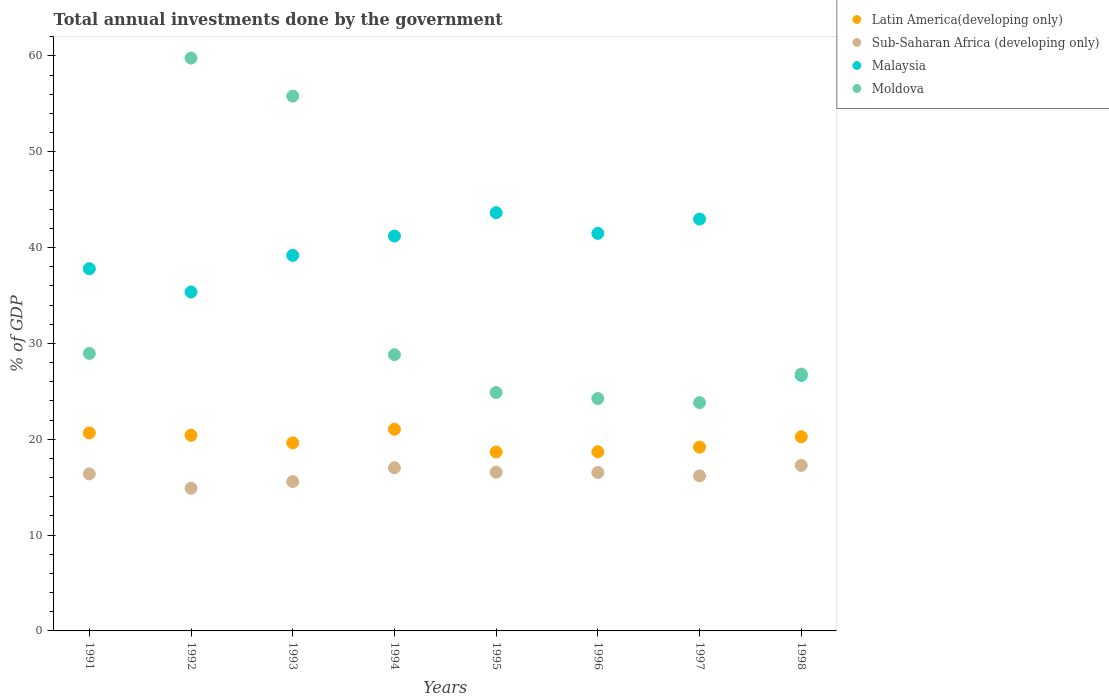How many different coloured dotlines are there?
Your response must be concise. 4. What is the total annual investments done by the government in Latin America(developing only) in 1991?
Your answer should be compact. 20.66. Across all years, what is the maximum total annual investments done by the government in Latin America(developing only)?
Offer a very short reply. 21.04. Across all years, what is the minimum total annual investments done by the government in Malaysia?
Your answer should be compact. 26.67. In which year was the total annual investments done by the government in Malaysia maximum?
Provide a short and direct response. 1995. In which year was the total annual investments done by the government in Moldova minimum?
Offer a very short reply. 1997. What is the total total annual investments done by the government in Sub-Saharan Africa (developing only) in the graph?
Offer a very short reply. 130.43. What is the difference between the total annual investments done by the government in Sub-Saharan Africa (developing only) in 1991 and that in 1995?
Provide a succinct answer. -0.18. What is the difference between the total annual investments done by the government in Latin America(developing only) in 1994 and the total annual investments done by the government in Sub-Saharan Africa (developing only) in 1997?
Your answer should be compact. 4.87. What is the average total annual investments done by the government in Sub-Saharan Africa (developing only) per year?
Provide a short and direct response. 16.3. In the year 1995, what is the difference between the total annual investments done by the government in Malaysia and total annual investments done by the government in Sub-Saharan Africa (developing only)?
Provide a succinct answer. 27.08. In how many years, is the total annual investments done by the government in Moldova greater than 16 %?
Ensure brevity in your answer.  8. What is the ratio of the total annual investments done by the government in Sub-Saharan Africa (developing only) in 1997 to that in 1998?
Offer a very short reply. 0.94. What is the difference between the highest and the second highest total annual investments done by the government in Sub-Saharan Africa (developing only)?
Make the answer very short. 0.25. What is the difference between the highest and the lowest total annual investments done by the government in Malaysia?
Offer a very short reply. 16.97. Is the sum of the total annual investments done by the government in Malaysia in 1995 and 1998 greater than the maximum total annual investments done by the government in Latin America(developing only) across all years?
Keep it short and to the point. Yes. Is it the case that in every year, the sum of the total annual investments done by the government in Malaysia and total annual investments done by the government in Latin America(developing only)  is greater than the total annual investments done by the government in Moldova?
Give a very brief answer. No. Is the total annual investments done by the government in Sub-Saharan Africa (developing only) strictly greater than the total annual investments done by the government in Malaysia over the years?
Your response must be concise. No. Is the total annual investments done by the government in Latin America(developing only) strictly less than the total annual investments done by the government in Malaysia over the years?
Offer a terse response. Yes. How many years are there in the graph?
Provide a short and direct response. 8. What is the difference between two consecutive major ticks on the Y-axis?
Make the answer very short. 10. Does the graph contain grids?
Offer a very short reply. No. Where does the legend appear in the graph?
Ensure brevity in your answer.  Top right. How many legend labels are there?
Make the answer very short. 4. How are the legend labels stacked?
Your response must be concise. Vertical. What is the title of the graph?
Your response must be concise. Total annual investments done by the government. Does "Iran" appear as one of the legend labels in the graph?
Make the answer very short. No. What is the label or title of the Y-axis?
Offer a terse response. % of GDP. What is the % of GDP in Latin America(developing only) in 1991?
Your answer should be compact. 20.66. What is the % of GDP of Sub-Saharan Africa (developing only) in 1991?
Ensure brevity in your answer.  16.38. What is the % of GDP of Malaysia in 1991?
Keep it short and to the point. 37.79. What is the % of GDP in Moldova in 1991?
Give a very brief answer. 28.96. What is the % of GDP of Latin America(developing only) in 1992?
Provide a short and direct response. 20.42. What is the % of GDP in Sub-Saharan Africa (developing only) in 1992?
Offer a very short reply. 14.89. What is the % of GDP in Malaysia in 1992?
Provide a short and direct response. 35.36. What is the % of GDP of Moldova in 1992?
Ensure brevity in your answer.  59.77. What is the % of GDP in Latin America(developing only) in 1993?
Your answer should be compact. 19.62. What is the % of GDP in Sub-Saharan Africa (developing only) in 1993?
Your answer should be very brief. 15.59. What is the % of GDP of Malaysia in 1993?
Ensure brevity in your answer.  39.18. What is the % of GDP of Moldova in 1993?
Your response must be concise. 55.8. What is the % of GDP in Latin America(developing only) in 1994?
Your answer should be very brief. 21.04. What is the % of GDP in Sub-Saharan Africa (developing only) in 1994?
Offer a very short reply. 17.03. What is the % of GDP of Malaysia in 1994?
Ensure brevity in your answer.  41.2. What is the % of GDP in Moldova in 1994?
Provide a short and direct response. 28.83. What is the % of GDP in Latin America(developing only) in 1995?
Provide a succinct answer. 18.67. What is the % of GDP in Sub-Saharan Africa (developing only) in 1995?
Your answer should be very brief. 16.56. What is the % of GDP in Malaysia in 1995?
Your response must be concise. 43.64. What is the % of GDP of Moldova in 1995?
Offer a terse response. 24.88. What is the % of GDP of Latin America(developing only) in 1996?
Make the answer very short. 18.69. What is the % of GDP of Sub-Saharan Africa (developing only) in 1996?
Offer a very short reply. 16.53. What is the % of GDP of Malaysia in 1996?
Offer a terse response. 41.48. What is the % of GDP of Moldova in 1996?
Make the answer very short. 24.25. What is the % of GDP in Latin America(developing only) in 1997?
Provide a short and direct response. 19.18. What is the % of GDP in Sub-Saharan Africa (developing only) in 1997?
Your answer should be very brief. 16.18. What is the % of GDP in Malaysia in 1997?
Provide a succinct answer. 42.97. What is the % of GDP of Moldova in 1997?
Give a very brief answer. 23.82. What is the % of GDP of Latin America(developing only) in 1998?
Keep it short and to the point. 20.26. What is the % of GDP in Sub-Saharan Africa (developing only) in 1998?
Keep it short and to the point. 17.28. What is the % of GDP in Malaysia in 1998?
Your answer should be very brief. 26.67. What is the % of GDP of Moldova in 1998?
Offer a very short reply. 26.8. Across all years, what is the maximum % of GDP in Latin America(developing only)?
Provide a succinct answer. 21.04. Across all years, what is the maximum % of GDP in Sub-Saharan Africa (developing only)?
Provide a short and direct response. 17.28. Across all years, what is the maximum % of GDP of Malaysia?
Ensure brevity in your answer.  43.64. Across all years, what is the maximum % of GDP of Moldova?
Make the answer very short. 59.77. Across all years, what is the minimum % of GDP in Latin America(developing only)?
Provide a short and direct response. 18.67. Across all years, what is the minimum % of GDP in Sub-Saharan Africa (developing only)?
Provide a succinct answer. 14.89. Across all years, what is the minimum % of GDP in Malaysia?
Your answer should be compact. 26.67. Across all years, what is the minimum % of GDP in Moldova?
Provide a short and direct response. 23.82. What is the total % of GDP of Latin America(developing only) in the graph?
Your response must be concise. 158.53. What is the total % of GDP in Sub-Saharan Africa (developing only) in the graph?
Make the answer very short. 130.43. What is the total % of GDP in Malaysia in the graph?
Your answer should be compact. 308.31. What is the total % of GDP of Moldova in the graph?
Offer a terse response. 273.1. What is the difference between the % of GDP of Latin America(developing only) in 1991 and that in 1992?
Ensure brevity in your answer.  0.24. What is the difference between the % of GDP in Sub-Saharan Africa (developing only) in 1991 and that in 1992?
Give a very brief answer. 1.5. What is the difference between the % of GDP in Malaysia in 1991 and that in 1992?
Your answer should be compact. 2.43. What is the difference between the % of GDP of Moldova in 1991 and that in 1992?
Provide a short and direct response. -30.81. What is the difference between the % of GDP of Latin America(developing only) in 1991 and that in 1993?
Offer a terse response. 1.04. What is the difference between the % of GDP in Sub-Saharan Africa (developing only) in 1991 and that in 1993?
Your response must be concise. 0.8. What is the difference between the % of GDP in Malaysia in 1991 and that in 1993?
Provide a succinct answer. -1.39. What is the difference between the % of GDP of Moldova in 1991 and that in 1993?
Provide a succinct answer. -26.84. What is the difference between the % of GDP of Latin America(developing only) in 1991 and that in 1994?
Offer a terse response. -0.39. What is the difference between the % of GDP of Sub-Saharan Africa (developing only) in 1991 and that in 1994?
Your response must be concise. -0.64. What is the difference between the % of GDP in Malaysia in 1991 and that in 1994?
Offer a very short reply. -3.41. What is the difference between the % of GDP in Moldova in 1991 and that in 1994?
Your answer should be compact. 0.13. What is the difference between the % of GDP in Latin America(developing only) in 1991 and that in 1995?
Provide a short and direct response. 1.99. What is the difference between the % of GDP in Sub-Saharan Africa (developing only) in 1991 and that in 1995?
Your answer should be compact. -0.18. What is the difference between the % of GDP of Malaysia in 1991 and that in 1995?
Ensure brevity in your answer.  -5.85. What is the difference between the % of GDP in Moldova in 1991 and that in 1995?
Your answer should be very brief. 4.08. What is the difference between the % of GDP of Latin America(developing only) in 1991 and that in 1996?
Provide a short and direct response. 1.97. What is the difference between the % of GDP of Sub-Saharan Africa (developing only) in 1991 and that in 1996?
Your answer should be compact. -0.14. What is the difference between the % of GDP of Malaysia in 1991 and that in 1996?
Keep it short and to the point. -3.69. What is the difference between the % of GDP in Moldova in 1991 and that in 1996?
Provide a short and direct response. 4.71. What is the difference between the % of GDP of Latin America(developing only) in 1991 and that in 1997?
Provide a succinct answer. 1.48. What is the difference between the % of GDP in Sub-Saharan Africa (developing only) in 1991 and that in 1997?
Provide a short and direct response. 0.21. What is the difference between the % of GDP of Malaysia in 1991 and that in 1997?
Your response must be concise. -5.18. What is the difference between the % of GDP of Moldova in 1991 and that in 1997?
Provide a succinct answer. 5.14. What is the difference between the % of GDP in Latin America(developing only) in 1991 and that in 1998?
Provide a short and direct response. 0.4. What is the difference between the % of GDP of Sub-Saharan Africa (developing only) in 1991 and that in 1998?
Ensure brevity in your answer.  -0.89. What is the difference between the % of GDP in Malaysia in 1991 and that in 1998?
Your answer should be very brief. 11.12. What is the difference between the % of GDP in Moldova in 1991 and that in 1998?
Make the answer very short. 2.16. What is the difference between the % of GDP of Latin America(developing only) in 1992 and that in 1993?
Provide a succinct answer. 0.8. What is the difference between the % of GDP in Sub-Saharan Africa (developing only) in 1992 and that in 1993?
Offer a terse response. -0.7. What is the difference between the % of GDP in Malaysia in 1992 and that in 1993?
Keep it short and to the point. -3.82. What is the difference between the % of GDP in Moldova in 1992 and that in 1993?
Your response must be concise. 3.97. What is the difference between the % of GDP of Latin America(developing only) in 1992 and that in 1994?
Provide a short and direct response. -0.63. What is the difference between the % of GDP of Sub-Saharan Africa (developing only) in 1992 and that in 1994?
Keep it short and to the point. -2.14. What is the difference between the % of GDP of Malaysia in 1992 and that in 1994?
Provide a short and direct response. -5.84. What is the difference between the % of GDP of Moldova in 1992 and that in 1994?
Your answer should be compact. 30.95. What is the difference between the % of GDP in Latin America(developing only) in 1992 and that in 1995?
Ensure brevity in your answer.  1.75. What is the difference between the % of GDP in Sub-Saharan Africa (developing only) in 1992 and that in 1995?
Offer a very short reply. -1.68. What is the difference between the % of GDP of Malaysia in 1992 and that in 1995?
Your answer should be very brief. -8.28. What is the difference between the % of GDP in Moldova in 1992 and that in 1995?
Provide a succinct answer. 34.89. What is the difference between the % of GDP in Latin America(developing only) in 1992 and that in 1996?
Provide a succinct answer. 1.72. What is the difference between the % of GDP of Sub-Saharan Africa (developing only) in 1992 and that in 1996?
Your response must be concise. -1.64. What is the difference between the % of GDP of Malaysia in 1992 and that in 1996?
Your answer should be very brief. -6.12. What is the difference between the % of GDP of Moldova in 1992 and that in 1996?
Make the answer very short. 35.52. What is the difference between the % of GDP of Latin America(developing only) in 1992 and that in 1997?
Offer a very short reply. 1.24. What is the difference between the % of GDP of Sub-Saharan Africa (developing only) in 1992 and that in 1997?
Your response must be concise. -1.29. What is the difference between the % of GDP of Malaysia in 1992 and that in 1997?
Offer a very short reply. -7.61. What is the difference between the % of GDP of Moldova in 1992 and that in 1997?
Your answer should be compact. 35.95. What is the difference between the % of GDP of Latin America(developing only) in 1992 and that in 1998?
Your response must be concise. 0.16. What is the difference between the % of GDP of Sub-Saharan Africa (developing only) in 1992 and that in 1998?
Offer a terse response. -2.39. What is the difference between the % of GDP of Malaysia in 1992 and that in 1998?
Your answer should be compact. 8.69. What is the difference between the % of GDP in Moldova in 1992 and that in 1998?
Provide a succinct answer. 32.97. What is the difference between the % of GDP in Latin America(developing only) in 1993 and that in 1994?
Provide a succinct answer. -1.43. What is the difference between the % of GDP in Sub-Saharan Africa (developing only) in 1993 and that in 1994?
Make the answer very short. -1.44. What is the difference between the % of GDP in Malaysia in 1993 and that in 1994?
Offer a very short reply. -2.02. What is the difference between the % of GDP of Moldova in 1993 and that in 1994?
Make the answer very short. 26.97. What is the difference between the % of GDP of Latin America(developing only) in 1993 and that in 1995?
Provide a short and direct response. 0.95. What is the difference between the % of GDP of Sub-Saharan Africa (developing only) in 1993 and that in 1995?
Give a very brief answer. -0.98. What is the difference between the % of GDP in Malaysia in 1993 and that in 1995?
Ensure brevity in your answer.  -4.46. What is the difference between the % of GDP in Moldova in 1993 and that in 1995?
Give a very brief answer. 30.92. What is the difference between the % of GDP of Latin America(developing only) in 1993 and that in 1996?
Provide a succinct answer. 0.93. What is the difference between the % of GDP of Sub-Saharan Africa (developing only) in 1993 and that in 1996?
Offer a terse response. -0.94. What is the difference between the % of GDP of Malaysia in 1993 and that in 1996?
Provide a short and direct response. -2.3. What is the difference between the % of GDP of Moldova in 1993 and that in 1996?
Your response must be concise. 31.55. What is the difference between the % of GDP in Latin America(developing only) in 1993 and that in 1997?
Your response must be concise. 0.44. What is the difference between the % of GDP in Sub-Saharan Africa (developing only) in 1993 and that in 1997?
Offer a terse response. -0.59. What is the difference between the % of GDP of Malaysia in 1993 and that in 1997?
Offer a very short reply. -3.79. What is the difference between the % of GDP in Moldova in 1993 and that in 1997?
Ensure brevity in your answer.  31.98. What is the difference between the % of GDP in Latin America(developing only) in 1993 and that in 1998?
Keep it short and to the point. -0.64. What is the difference between the % of GDP of Sub-Saharan Africa (developing only) in 1993 and that in 1998?
Ensure brevity in your answer.  -1.69. What is the difference between the % of GDP of Malaysia in 1993 and that in 1998?
Your answer should be very brief. 12.51. What is the difference between the % of GDP in Moldova in 1993 and that in 1998?
Keep it short and to the point. 29. What is the difference between the % of GDP in Latin America(developing only) in 1994 and that in 1995?
Provide a short and direct response. 2.37. What is the difference between the % of GDP of Sub-Saharan Africa (developing only) in 1994 and that in 1995?
Offer a very short reply. 0.46. What is the difference between the % of GDP of Malaysia in 1994 and that in 1995?
Make the answer very short. -2.44. What is the difference between the % of GDP in Moldova in 1994 and that in 1995?
Provide a short and direct response. 3.95. What is the difference between the % of GDP in Latin America(developing only) in 1994 and that in 1996?
Provide a short and direct response. 2.35. What is the difference between the % of GDP in Sub-Saharan Africa (developing only) in 1994 and that in 1996?
Keep it short and to the point. 0.5. What is the difference between the % of GDP in Malaysia in 1994 and that in 1996?
Make the answer very short. -0.28. What is the difference between the % of GDP of Moldova in 1994 and that in 1996?
Keep it short and to the point. 4.58. What is the difference between the % of GDP of Latin America(developing only) in 1994 and that in 1997?
Offer a terse response. 1.87. What is the difference between the % of GDP in Sub-Saharan Africa (developing only) in 1994 and that in 1997?
Ensure brevity in your answer.  0.85. What is the difference between the % of GDP in Malaysia in 1994 and that in 1997?
Make the answer very short. -1.77. What is the difference between the % of GDP of Moldova in 1994 and that in 1997?
Offer a very short reply. 5. What is the difference between the % of GDP in Latin America(developing only) in 1994 and that in 1998?
Give a very brief answer. 0.79. What is the difference between the % of GDP of Sub-Saharan Africa (developing only) in 1994 and that in 1998?
Give a very brief answer. -0.25. What is the difference between the % of GDP of Malaysia in 1994 and that in 1998?
Ensure brevity in your answer.  14.53. What is the difference between the % of GDP of Moldova in 1994 and that in 1998?
Provide a succinct answer. 2.02. What is the difference between the % of GDP in Latin America(developing only) in 1995 and that in 1996?
Give a very brief answer. -0.02. What is the difference between the % of GDP of Sub-Saharan Africa (developing only) in 1995 and that in 1996?
Provide a short and direct response. 0.04. What is the difference between the % of GDP in Malaysia in 1995 and that in 1996?
Your answer should be very brief. 2.16. What is the difference between the % of GDP of Moldova in 1995 and that in 1996?
Provide a short and direct response. 0.63. What is the difference between the % of GDP in Latin America(developing only) in 1995 and that in 1997?
Make the answer very short. -0.51. What is the difference between the % of GDP in Sub-Saharan Africa (developing only) in 1995 and that in 1997?
Provide a succinct answer. 0.39. What is the difference between the % of GDP in Malaysia in 1995 and that in 1997?
Offer a terse response. 0.67. What is the difference between the % of GDP of Moldova in 1995 and that in 1997?
Make the answer very short. 1.05. What is the difference between the % of GDP in Latin America(developing only) in 1995 and that in 1998?
Your response must be concise. -1.59. What is the difference between the % of GDP of Sub-Saharan Africa (developing only) in 1995 and that in 1998?
Your response must be concise. -0.71. What is the difference between the % of GDP of Malaysia in 1995 and that in 1998?
Provide a succinct answer. 16.97. What is the difference between the % of GDP in Moldova in 1995 and that in 1998?
Provide a short and direct response. -1.93. What is the difference between the % of GDP of Latin America(developing only) in 1996 and that in 1997?
Make the answer very short. -0.49. What is the difference between the % of GDP of Sub-Saharan Africa (developing only) in 1996 and that in 1997?
Your response must be concise. 0.35. What is the difference between the % of GDP in Malaysia in 1996 and that in 1997?
Offer a very short reply. -1.49. What is the difference between the % of GDP in Moldova in 1996 and that in 1997?
Your answer should be compact. 0.43. What is the difference between the % of GDP of Latin America(developing only) in 1996 and that in 1998?
Offer a terse response. -1.57. What is the difference between the % of GDP of Sub-Saharan Africa (developing only) in 1996 and that in 1998?
Your answer should be very brief. -0.75. What is the difference between the % of GDP of Malaysia in 1996 and that in 1998?
Ensure brevity in your answer.  14.8. What is the difference between the % of GDP in Moldova in 1996 and that in 1998?
Keep it short and to the point. -2.55. What is the difference between the % of GDP of Latin America(developing only) in 1997 and that in 1998?
Your answer should be very brief. -1.08. What is the difference between the % of GDP of Sub-Saharan Africa (developing only) in 1997 and that in 1998?
Offer a very short reply. -1.1. What is the difference between the % of GDP in Malaysia in 1997 and that in 1998?
Give a very brief answer. 16.3. What is the difference between the % of GDP of Moldova in 1997 and that in 1998?
Your answer should be very brief. -2.98. What is the difference between the % of GDP of Latin America(developing only) in 1991 and the % of GDP of Sub-Saharan Africa (developing only) in 1992?
Your answer should be very brief. 5.77. What is the difference between the % of GDP of Latin America(developing only) in 1991 and the % of GDP of Malaysia in 1992?
Provide a succinct answer. -14.71. What is the difference between the % of GDP in Latin America(developing only) in 1991 and the % of GDP in Moldova in 1992?
Offer a very short reply. -39.11. What is the difference between the % of GDP in Sub-Saharan Africa (developing only) in 1991 and the % of GDP in Malaysia in 1992?
Give a very brief answer. -18.98. What is the difference between the % of GDP of Sub-Saharan Africa (developing only) in 1991 and the % of GDP of Moldova in 1992?
Offer a terse response. -43.39. What is the difference between the % of GDP in Malaysia in 1991 and the % of GDP in Moldova in 1992?
Your response must be concise. -21.98. What is the difference between the % of GDP of Latin America(developing only) in 1991 and the % of GDP of Sub-Saharan Africa (developing only) in 1993?
Ensure brevity in your answer.  5.07. What is the difference between the % of GDP in Latin America(developing only) in 1991 and the % of GDP in Malaysia in 1993?
Make the answer very short. -18.53. What is the difference between the % of GDP of Latin America(developing only) in 1991 and the % of GDP of Moldova in 1993?
Your answer should be compact. -35.14. What is the difference between the % of GDP of Sub-Saharan Africa (developing only) in 1991 and the % of GDP of Malaysia in 1993?
Your answer should be compact. -22.8. What is the difference between the % of GDP of Sub-Saharan Africa (developing only) in 1991 and the % of GDP of Moldova in 1993?
Offer a terse response. -39.42. What is the difference between the % of GDP of Malaysia in 1991 and the % of GDP of Moldova in 1993?
Offer a very short reply. -18.01. What is the difference between the % of GDP in Latin America(developing only) in 1991 and the % of GDP in Sub-Saharan Africa (developing only) in 1994?
Your response must be concise. 3.63. What is the difference between the % of GDP of Latin America(developing only) in 1991 and the % of GDP of Malaysia in 1994?
Make the answer very short. -20.54. What is the difference between the % of GDP in Latin America(developing only) in 1991 and the % of GDP in Moldova in 1994?
Your answer should be very brief. -8.17. What is the difference between the % of GDP of Sub-Saharan Africa (developing only) in 1991 and the % of GDP of Malaysia in 1994?
Give a very brief answer. -24.82. What is the difference between the % of GDP in Sub-Saharan Africa (developing only) in 1991 and the % of GDP in Moldova in 1994?
Give a very brief answer. -12.44. What is the difference between the % of GDP of Malaysia in 1991 and the % of GDP of Moldova in 1994?
Your answer should be compact. 8.97. What is the difference between the % of GDP in Latin America(developing only) in 1991 and the % of GDP in Sub-Saharan Africa (developing only) in 1995?
Ensure brevity in your answer.  4.09. What is the difference between the % of GDP in Latin America(developing only) in 1991 and the % of GDP in Malaysia in 1995?
Ensure brevity in your answer.  -22.98. What is the difference between the % of GDP of Latin America(developing only) in 1991 and the % of GDP of Moldova in 1995?
Make the answer very short. -4.22. What is the difference between the % of GDP of Sub-Saharan Africa (developing only) in 1991 and the % of GDP of Malaysia in 1995?
Provide a succinct answer. -27.26. What is the difference between the % of GDP in Sub-Saharan Africa (developing only) in 1991 and the % of GDP in Moldova in 1995?
Keep it short and to the point. -8.49. What is the difference between the % of GDP of Malaysia in 1991 and the % of GDP of Moldova in 1995?
Your response must be concise. 12.91. What is the difference between the % of GDP of Latin America(developing only) in 1991 and the % of GDP of Sub-Saharan Africa (developing only) in 1996?
Ensure brevity in your answer.  4.13. What is the difference between the % of GDP in Latin America(developing only) in 1991 and the % of GDP in Malaysia in 1996?
Provide a short and direct response. -20.82. What is the difference between the % of GDP of Latin America(developing only) in 1991 and the % of GDP of Moldova in 1996?
Offer a very short reply. -3.59. What is the difference between the % of GDP in Sub-Saharan Africa (developing only) in 1991 and the % of GDP in Malaysia in 1996?
Offer a terse response. -25.1. What is the difference between the % of GDP of Sub-Saharan Africa (developing only) in 1991 and the % of GDP of Moldova in 1996?
Make the answer very short. -7.86. What is the difference between the % of GDP in Malaysia in 1991 and the % of GDP in Moldova in 1996?
Ensure brevity in your answer.  13.54. What is the difference between the % of GDP of Latin America(developing only) in 1991 and the % of GDP of Sub-Saharan Africa (developing only) in 1997?
Your answer should be compact. 4.48. What is the difference between the % of GDP in Latin America(developing only) in 1991 and the % of GDP in Malaysia in 1997?
Provide a succinct answer. -22.32. What is the difference between the % of GDP of Latin America(developing only) in 1991 and the % of GDP of Moldova in 1997?
Ensure brevity in your answer.  -3.16. What is the difference between the % of GDP in Sub-Saharan Africa (developing only) in 1991 and the % of GDP in Malaysia in 1997?
Provide a short and direct response. -26.59. What is the difference between the % of GDP in Sub-Saharan Africa (developing only) in 1991 and the % of GDP in Moldova in 1997?
Your answer should be compact. -7.44. What is the difference between the % of GDP of Malaysia in 1991 and the % of GDP of Moldova in 1997?
Provide a short and direct response. 13.97. What is the difference between the % of GDP in Latin America(developing only) in 1991 and the % of GDP in Sub-Saharan Africa (developing only) in 1998?
Ensure brevity in your answer.  3.38. What is the difference between the % of GDP of Latin America(developing only) in 1991 and the % of GDP of Malaysia in 1998?
Your answer should be compact. -6.02. What is the difference between the % of GDP in Latin America(developing only) in 1991 and the % of GDP in Moldova in 1998?
Make the answer very short. -6.14. What is the difference between the % of GDP of Sub-Saharan Africa (developing only) in 1991 and the % of GDP of Malaysia in 1998?
Ensure brevity in your answer.  -10.29. What is the difference between the % of GDP in Sub-Saharan Africa (developing only) in 1991 and the % of GDP in Moldova in 1998?
Provide a succinct answer. -10.42. What is the difference between the % of GDP of Malaysia in 1991 and the % of GDP of Moldova in 1998?
Your answer should be very brief. 10.99. What is the difference between the % of GDP in Latin America(developing only) in 1992 and the % of GDP in Sub-Saharan Africa (developing only) in 1993?
Offer a terse response. 4.83. What is the difference between the % of GDP in Latin America(developing only) in 1992 and the % of GDP in Malaysia in 1993?
Your answer should be very brief. -18.77. What is the difference between the % of GDP in Latin America(developing only) in 1992 and the % of GDP in Moldova in 1993?
Your answer should be very brief. -35.38. What is the difference between the % of GDP in Sub-Saharan Africa (developing only) in 1992 and the % of GDP in Malaysia in 1993?
Give a very brief answer. -24.3. What is the difference between the % of GDP in Sub-Saharan Africa (developing only) in 1992 and the % of GDP in Moldova in 1993?
Provide a short and direct response. -40.91. What is the difference between the % of GDP of Malaysia in 1992 and the % of GDP of Moldova in 1993?
Provide a short and direct response. -20.44. What is the difference between the % of GDP in Latin America(developing only) in 1992 and the % of GDP in Sub-Saharan Africa (developing only) in 1994?
Your answer should be compact. 3.39. What is the difference between the % of GDP of Latin America(developing only) in 1992 and the % of GDP of Malaysia in 1994?
Offer a terse response. -20.79. What is the difference between the % of GDP of Latin America(developing only) in 1992 and the % of GDP of Moldova in 1994?
Your response must be concise. -8.41. What is the difference between the % of GDP of Sub-Saharan Africa (developing only) in 1992 and the % of GDP of Malaysia in 1994?
Your answer should be very brief. -26.32. What is the difference between the % of GDP of Sub-Saharan Africa (developing only) in 1992 and the % of GDP of Moldova in 1994?
Give a very brief answer. -13.94. What is the difference between the % of GDP in Malaysia in 1992 and the % of GDP in Moldova in 1994?
Offer a very short reply. 6.54. What is the difference between the % of GDP of Latin America(developing only) in 1992 and the % of GDP of Sub-Saharan Africa (developing only) in 1995?
Provide a short and direct response. 3.85. What is the difference between the % of GDP in Latin America(developing only) in 1992 and the % of GDP in Malaysia in 1995?
Offer a very short reply. -23.22. What is the difference between the % of GDP in Latin America(developing only) in 1992 and the % of GDP in Moldova in 1995?
Ensure brevity in your answer.  -4.46. What is the difference between the % of GDP in Sub-Saharan Africa (developing only) in 1992 and the % of GDP in Malaysia in 1995?
Give a very brief answer. -28.75. What is the difference between the % of GDP of Sub-Saharan Africa (developing only) in 1992 and the % of GDP of Moldova in 1995?
Your answer should be compact. -9.99. What is the difference between the % of GDP in Malaysia in 1992 and the % of GDP in Moldova in 1995?
Your answer should be very brief. 10.49. What is the difference between the % of GDP of Latin America(developing only) in 1992 and the % of GDP of Sub-Saharan Africa (developing only) in 1996?
Give a very brief answer. 3.89. What is the difference between the % of GDP in Latin America(developing only) in 1992 and the % of GDP in Malaysia in 1996?
Keep it short and to the point. -21.06. What is the difference between the % of GDP in Latin America(developing only) in 1992 and the % of GDP in Moldova in 1996?
Keep it short and to the point. -3.83. What is the difference between the % of GDP in Sub-Saharan Africa (developing only) in 1992 and the % of GDP in Malaysia in 1996?
Offer a terse response. -26.59. What is the difference between the % of GDP in Sub-Saharan Africa (developing only) in 1992 and the % of GDP in Moldova in 1996?
Keep it short and to the point. -9.36. What is the difference between the % of GDP in Malaysia in 1992 and the % of GDP in Moldova in 1996?
Provide a succinct answer. 11.12. What is the difference between the % of GDP of Latin America(developing only) in 1992 and the % of GDP of Sub-Saharan Africa (developing only) in 1997?
Provide a short and direct response. 4.24. What is the difference between the % of GDP in Latin America(developing only) in 1992 and the % of GDP in Malaysia in 1997?
Your answer should be compact. -22.56. What is the difference between the % of GDP of Latin America(developing only) in 1992 and the % of GDP of Moldova in 1997?
Make the answer very short. -3.41. What is the difference between the % of GDP in Sub-Saharan Africa (developing only) in 1992 and the % of GDP in Malaysia in 1997?
Ensure brevity in your answer.  -28.09. What is the difference between the % of GDP in Sub-Saharan Africa (developing only) in 1992 and the % of GDP in Moldova in 1997?
Your answer should be compact. -8.94. What is the difference between the % of GDP in Malaysia in 1992 and the % of GDP in Moldova in 1997?
Your answer should be very brief. 11.54. What is the difference between the % of GDP of Latin America(developing only) in 1992 and the % of GDP of Sub-Saharan Africa (developing only) in 1998?
Make the answer very short. 3.14. What is the difference between the % of GDP in Latin America(developing only) in 1992 and the % of GDP in Malaysia in 1998?
Give a very brief answer. -6.26. What is the difference between the % of GDP of Latin America(developing only) in 1992 and the % of GDP of Moldova in 1998?
Provide a succinct answer. -6.39. What is the difference between the % of GDP of Sub-Saharan Africa (developing only) in 1992 and the % of GDP of Malaysia in 1998?
Your answer should be very brief. -11.79. What is the difference between the % of GDP in Sub-Saharan Africa (developing only) in 1992 and the % of GDP in Moldova in 1998?
Ensure brevity in your answer.  -11.92. What is the difference between the % of GDP in Malaysia in 1992 and the % of GDP in Moldova in 1998?
Give a very brief answer. 8.56. What is the difference between the % of GDP in Latin America(developing only) in 1993 and the % of GDP in Sub-Saharan Africa (developing only) in 1994?
Keep it short and to the point. 2.59. What is the difference between the % of GDP in Latin America(developing only) in 1993 and the % of GDP in Malaysia in 1994?
Offer a very short reply. -21.59. What is the difference between the % of GDP of Latin America(developing only) in 1993 and the % of GDP of Moldova in 1994?
Offer a very short reply. -9.21. What is the difference between the % of GDP of Sub-Saharan Africa (developing only) in 1993 and the % of GDP of Malaysia in 1994?
Your answer should be very brief. -25.62. What is the difference between the % of GDP of Sub-Saharan Africa (developing only) in 1993 and the % of GDP of Moldova in 1994?
Keep it short and to the point. -13.24. What is the difference between the % of GDP in Malaysia in 1993 and the % of GDP in Moldova in 1994?
Your response must be concise. 10.36. What is the difference between the % of GDP in Latin America(developing only) in 1993 and the % of GDP in Sub-Saharan Africa (developing only) in 1995?
Ensure brevity in your answer.  3.05. What is the difference between the % of GDP in Latin America(developing only) in 1993 and the % of GDP in Malaysia in 1995?
Provide a succinct answer. -24.02. What is the difference between the % of GDP in Latin America(developing only) in 1993 and the % of GDP in Moldova in 1995?
Your answer should be very brief. -5.26. What is the difference between the % of GDP in Sub-Saharan Africa (developing only) in 1993 and the % of GDP in Malaysia in 1995?
Provide a succinct answer. -28.05. What is the difference between the % of GDP of Sub-Saharan Africa (developing only) in 1993 and the % of GDP of Moldova in 1995?
Provide a short and direct response. -9.29. What is the difference between the % of GDP of Malaysia in 1993 and the % of GDP of Moldova in 1995?
Your answer should be very brief. 14.31. What is the difference between the % of GDP of Latin America(developing only) in 1993 and the % of GDP of Sub-Saharan Africa (developing only) in 1996?
Offer a very short reply. 3.09. What is the difference between the % of GDP of Latin America(developing only) in 1993 and the % of GDP of Malaysia in 1996?
Give a very brief answer. -21.86. What is the difference between the % of GDP in Latin America(developing only) in 1993 and the % of GDP in Moldova in 1996?
Provide a succinct answer. -4.63. What is the difference between the % of GDP of Sub-Saharan Africa (developing only) in 1993 and the % of GDP of Malaysia in 1996?
Offer a very short reply. -25.89. What is the difference between the % of GDP in Sub-Saharan Africa (developing only) in 1993 and the % of GDP in Moldova in 1996?
Offer a terse response. -8.66. What is the difference between the % of GDP in Malaysia in 1993 and the % of GDP in Moldova in 1996?
Your response must be concise. 14.94. What is the difference between the % of GDP in Latin America(developing only) in 1993 and the % of GDP in Sub-Saharan Africa (developing only) in 1997?
Provide a short and direct response. 3.44. What is the difference between the % of GDP of Latin America(developing only) in 1993 and the % of GDP of Malaysia in 1997?
Ensure brevity in your answer.  -23.36. What is the difference between the % of GDP in Latin America(developing only) in 1993 and the % of GDP in Moldova in 1997?
Provide a succinct answer. -4.2. What is the difference between the % of GDP in Sub-Saharan Africa (developing only) in 1993 and the % of GDP in Malaysia in 1997?
Provide a succinct answer. -27.39. What is the difference between the % of GDP in Sub-Saharan Africa (developing only) in 1993 and the % of GDP in Moldova in 1997?
Make the answer very short. -8.24. What is the difference between the % of GDP in Malaysia in 1993 and the % of GDP in Moldova in 1997?
Your answer should be compact. 15.36. What is the difference between the % of GDP of Latin America(developing only) in 1993 and the % of GDP of Sub-Saharan Africa (developing only) in 1998?
Provide a short and direct response. 2.34. What is the difference between the % of GDP in Latin America(developing only) in 1993 and the % of GDP in Malaysia in 1998?
Offer a very short reply. -7.06. What is the difference between the % of GDP of Latin America(developing only) in 1993 and the % of GDP of Moldova in 1998?
Provide a short and direct response. -7.18. What is the difference between the % of GDP of Sub-Saharan Africa (developing only) in 1993 and the % of GDP of Malaysia in 1998?
Keep it short and to the point. -11.09. What is the difference between the % of GDP of Sub-Saharan Africa (developing only) in 1993 and the % of GDP of Moldova in 1998?
Your response must be concise. -11.21. What is the difference between the % of GDP of Malaysia in 1993 and the % of GDP of Moldova in 1998?
Your answer should be very brief. 12.38. What is the difference between the % of GDP of Latin America(developing only) in 1994 and the % of GDP of Sub-Saharan Africa (developing only) in 1995?
Offer a very short reply. 4.48. What is the difference between the % of GDP in Latin America(developing only) in 1994 and the % of GDP in Malaysia in 1995?
Ensure brevity in your answer.  -22.6. What is the difference between the % of GDP in Latin America(developing only) in 1994 and the % of GDP in Moldova in 1995?
Keep it short and to the point. -3.83. What is the difference between the % of GDP of Sub-Saharan Africa (developing only) in 1994 and the % of GDP of Malaysia in 1995?
Give a very brief answer. -26.61. What is the difference between the % of GDP of Sub-Saharan Africa (developing only) in 1994 and the % of GDP of Moldova in 1995?
Your response must be concise. -7.85. What is the difference between the % of GDP of Malaysia in 1994 and the % of GDP of Moldova in 1995?
Make the answer very short. 16.33. What is the difference between the % of GDP in Latin America(developing only) in 1994 and the % of GDP in Sub-Saharan Africa (developing only) in 1996?
Provide a short and direct response. 4.52. What is the difference between the % of GDP of Latin America(developing only) in 1994 and the % of GDP of Malaysia in 1996?
Your answer should be very brief. -20.44. What is the difference between the % of GDP of Latin America(developing only) in 1994 and the % of GDP of Moldova in 1996?
Keep it short and to the point. -3.2. What is the difference between the % of GDP of Sub-Saharan Africa (developing only) in 1994 and the % of GDP of Malaysia in 1996?
Keep it short and to the point. -24.45. What is the difference between the % of GDP of Sub-Saharan Africa (developing only) in 1994 and the % of GDP of Moldova in 1996?
Give a very brief answer. -7.22. What is the difference between the % of GDP in Malaysia in 1994 and the % of GDP in Moldova in 1996?
Give a very brief answer. 16.96. What is the difference between the % of GDP of Latin America(developing only) in 1994 and the % of GDP of Sub-Saharan Africa (developing only) in 1997?
Provide a short and direct response. 4.87. What is the difference between the % of GDP in Latin America(developing only) in 1994 and the % of GDP in Malaysia in 1997?
Provide a succinct answer. -21.93. What is the difference between the % of GDP of Latin America(developing only) in 1994 and the % of GDP of Moldova in 1997?
Provide a succinct answer. -2.78. What is the difference between the % of GDP in Sub-Saharan Africa (developing only) in 1994 and the % of GDP in Malaysia in 1997?
Ensure brevity in your answer.  -25.95. What is the difference between the % of GDP in Sub-Saharan Africa (developing only) in 1994 and the % of GDP in Moldova in 1997?
Offer a terse response. -6.8. What is the difference between the % of GDP of Malaysia in 1994 and the % of GDP of Moldova in 1997?
Provide a succinct answer. 17.38. What is the difference between the % of GDP in Latin America(developing only) in 1994 and the % of GDP in Sub-Saharan Africa (developing only) in 1998?
Provide a succinct answer. 3.77. What is the difference between the % of GDP in Latin America(developing only) in 1994 and the % of GDP in Malaysia in 1998?
Your answer should be very brief. -5.63. What is the difference between the % of GDP of Latin America(developing only) in 1994 and the % of GDP of Moldova in 1998?
Offer a very short reply. -5.76. What is the difference between the % of GDP in Sub-Saharan Africa (developing only) in 1994 and the % of GDP in Malaysia in 1998?
Your answer should be very brief. -9.65. What is the difference between the % of GDP of Sub-Saharan Africa (developing only) in 1994 and the % of GDP of Moldova in 1998?
Your response must be concise. -9.77. What is the difference between the % of GDP in Malaysia in 1994 and the % of GDP in Moldova in 1998?
Your answer should be compact. 14.4. What is the difference between the % of GDP of Latin America(developing only) in 1995 and the % of GDP of Sub-Saharan Africa (developing only) in 1996?
Make the answer very short. 2.14. What is the difference between the % of GDP of Latin America(developing only) in 1995 and the % of GDP of Malaysia in 1996?
Your answer should be compact. -22.81. What is the difference between the % of GDP of Latin America(developing only) in 1995 and the % of GDP of Moldova in 1996?
Provide a short and direct response. -5.58. What is the difference between the % of GDP in Sub-Saharan Africa (developing only) in 1995 and the % of GDP in Malaysia in 1996?
Give a very brief answer. -24.91. What is the difference between the % of GDP of Sub-Saharan Africa (developing only) in 1995 and the % of GDP of Moldova in 1996?
Keep it short and to the point. -7.68. What is the difference between the % of GDP in Malaysia in 1995 and the % of GDP in Moldova in 1996?
Your answer should be very brief. 19.39. What is the difference between the % of GDP in Latin America(developing only) in 1995 and the % of GDP in Sub-Saharan Africa (developing only) in 1997?
Provide a short and direct response. 2.49. What is the difference between the % of GDP of Latin America(developing only) in 1995 and the % of GDP of Malaysia in 1997?
Your answer should be very brief. -24.3. What is the difference between the % of GDP of Latin America(developing only) in 1995 and the % of GDP of Moldova in 1997?
Give a very brief answer. -5.15. What is the difference between the % of GDP in Sub-Saharan Africa (developing only) in 1995 and the % of GDP in Malaysia in 1997?
Keep it short and to the point. -26.41. What is the difference between the % of GDP of Sub-Saharan Africa (developing only) in 1995 and the % of GDP of Moldova in 1997?
Make the answer very short. -7.26. What is the difference between the % of GDP in Malaysia in 1995 and the % of GDP in Moldova in 1997?
Keep it short and to the point. 19.82. What is the difference between the % of GDP of Latin America(developing only) in 1995 and the % of GDP of Sub-Saharan Africa (developing only) in 1998?
Your response must be concise. 1.39. What is the difference between the % of GDP of Latin America(developing only) in 1995 and the % of GDP of Malaysia in 1998?
Your answer should be very brief. -8. What is the difference between the % of GDP in Latin America(developing only) in 1995 and the % of GDP in Moldova in 1998?
Make the answer very short. -8.13. What is the difference between the % of GDP of Sub-Saharan Africa (developing only) in 1995 and the % of GDP of Malaysia in 1998?
Your answer should be very brief. -10.11. What is the difference between the % of GDP of Sub-Saharan Africa (developing only) in 1995 and the % of GDP of Moldova in 1998?
Ensure brevity in your answer.  -10.24. What is the difference between the % of GDP in Malaysia in 1995 and the % of GDP in Moldova in 1998?
Offer a very short reply. 16.84. What is the difference between the % of GDP in Latin America(developing only) in 1996 and the % of GDP in Sub-Saharan Africa (developing only) in 1997?
Make the answer very short. 2.51. What is the difference between the % of GDP in Latin America(developing only) in 1996 and the % of GDP in Malaysia in 1997?
Your answer should be compact. -24.28. What is the difference between the % of GDP of Latin America(developing only) in 1996 and the % of GDP of Moldova in 1997?
Your response must be concise. -5.13. What is the difference between the % of GDP of Sub-Saharan Africa (developing only) in 1996 and the % of GDP of Malaysia in 1997?
Your response must be concise. -26.45. What is the difference between the % of GDP of Sub-Saharan Africa (developing only) in 1996 and the % of GDP of Moldova in 1997?
Your response must be concise. -7.29. What is the difference between the % of GDP of Malaysia in 1996 and the % of GDP of Moldova in 1997?
Your response must be concise. 17.66. What is the difference between the % of GDP in Latin America(developing only) in 1996 and the % of GDP in Sub-Saharan Africa (developing only) in 1998?
Keep it short and to the point. 1.41. What is the difference between the % of GDP of Latin America(developing only) in 1996 and the % of GDP of Malaysia in 1998?
Make the answer very short. -7.98. What is the difference between the % of GDP in Latin America(developing only) in 1996 and the % of GDP in Moldova in 1998?
Provide a succinct answer. -8.11. What is the difference between the % of GDP in Sub-Saharan Africa (developing only) in 1996 and the % of GDP in Malaysia in 1998?
Your answer should be compact. -10.15. What is the difference between the % of GDP of Sub-Saharan Africa (developing only) in 1996 and the % of GDP of Moldova in 1998?
Offer a very short reply. -10.27. What is the difference between the % of GDP of Malaysia in 1996 and the % of GDP of Moldova in 1998?
Your answer should be very brief. 14.68. What is the difference between the % of GDP in Latin America(developing only) in 1997 and the % of GDP in Sub-Saharan Africa (developing only) in 1998?
Provide a short and direct response. 1.9. What is the difference between the % of GDP of Latin America(developing only) in 1997 and the % of GDP of Malaysia in 1998?
Make the answer very short. -7.5. What is the difference between the % of GDP in Latin America(developing only) in 1997 and the % of GDP in Moldova in 1998?
Offer a terse response. -7.62. What is the difference between the % of GDP in Sub-Saharan Africa (developing only) in 1997 and the % of GDP in Malaysia in 1998?
Your response must be concise. -10.5. What is the difference between the % of GDP of Sub-Saharan Africa (developing only) in 1997 and the % of GDP of Moldova in 1998?
Ensure brevity in your answer.  -10.62. What is the difference between the % of GDP in Malaysia in 1997 and the % of GDP in Moldova in 1998?
Offer a terse response. 16.17. What is the average % of GDP of Latin America(developing only) per year?
Give a very brief answer. 19.82. What is the average % of GDP of Sub-Saharan Africa (developing only) per year?
Keep it short and to the point. 16.3. What is the average % of GDP of Malaysia per year?
Offer a terse response. 38.54. What is the average % of GDP of Moldova per year?
Your answer should be very brief. 34.14. In the year 1991, what is the difference between the % of GDP in Latin America(developing only) and % of GDP in Sub-Saharan Africa (developing only)?
Your answer should be compact. 4.27. In the year 1991, what is the difference between the % of GDP in Latin America(developing only) and % of GDP in Malaysia?
Keep it short and to the point. -17.13. In the year 1991, what is the difference between the % of GDP in Latin America(developing only) and % of GDP in Moldova?
Your answer should be compact. -8.3. In the year 1991, what is the difference between the % of GDP in Sub-Saharan Africa (developing only) and % of GDP in Malaysia?
Provide a short and direct response. -21.41. In the year 1991, what is the difference between the % of GDP of Sub-Saharan Africa (developing only) and % of GDP of Moldova?
Your answer should be very brief. -12.57. In the year 1991, what is the difference between the % of GDP in Malaysia and % of GDP in Moldova?
Provide a short and direct response. 8.83. In the year 1992, what is the difference between the % of GDP of Latin America(developing only) and % of GDP of Sub-Saharan Africa (developing only)?
Your answer should be very brief. 5.53. In the year 1992, what is the difference between the % of GDP of Latin America(developing only) and % of GDP of Malaysia?
Give a very brief answer. -14.95. In the year 1992, what is the difference between the % of GDP in Latin America(developing only) and % of GDP in Moldova?
Provide a short and direct response. -39.36. In the year 1992, what is the difference between the % of GDP of Sub-Saharan Africa (developing only) and % of GDP of Malaysia?
Your response must be concise. -20.48. In the year 1992, what is the difference between the % of GDP of Sub-Saharan Africa (developing only) and % of GDP of Moldova?
Give a very brief answer. -44.88. In the year 1992, what is the difference between the % of GDP of Malaysia and % of GDP of Moldova?
Provide a short and direct response. -24.41. In the year 1993, what is the difference between the % of GDP in Latin America(developing only) and % of GDP in Sub-Saharan Africa (developing only)?
Keep it short and to the point. 4.03. In the year 1993, what is the difference between the % of GDP of Latin America(developing only) and % of GDP of Malaysia?
Give a very brief answer. -19.57. In the year 1993, what is the difference between the % of GDP of Latin America(developing only) and % of GDP of Moldova?
Provide a short and direct response. -36.18. In the year 1993, what is the difference between the % of GDP of Sub-Saharan Africa (developing only) and % of GDP of Malaysia?
Keep it short and to the point. -23.6. In the year 1993, what is the difference between the % of GDP in Sub-Saharan Africa (developing only) and % of GDP in Moldova?
Ensure brevity in your answer.  -40.21. In the year 1993, what is the difference between the % of GDP of Malaysia and % of GDP of Moldova?
Make the answer very short. -16.62. In the year 1994, what is the difference between the % of GDP in Latin America(developing only) and % of GDP in Sub-Saharan Africa (developing only)?
Offer a terse response. 4.02. In the year 1994, what is the difference between the % of GDP in Latin America(developing only) and % of GDP in Malaysia?
Your answer should be very brief. -20.16. In the year 1994, what is the difference between the % of GDP in Latin America(developing only) and % of GDP in Moldova?
Keep it short and to the point. -7.78. In the year 1994, what is the difference between the % of GDP of Sub-Saharan Africa (developing only) and % of GDP of Malaysia?
Your response must be concise. -24.18. In the year 1994, what is the difference between the % of GDP of Sub-Saharan Africa (developing only) and % of GDP of Moldova?
Your answer should be compact. -11.8. In the year 1994, what is the difference between the % of GDP in Malaysia and % of GDP in Moldova?
Keep it short and to the point. 12.38. In the year 1995, what is the difference between the % of GDP of Latin America(developing only) and % of GDP of Sub-Saharan Africa (developing only)?
Your response must be concise. 2.11. In the year 1995, what is the difference between the % of GDP of Latin America(developing only) and % of GDP of Malaysia?
Make the answer very short. -24.97. In the year 1995, what is the difference between the % of GDP in Latin America(developing only) and % of GDP in Moldova?
Provide a short and direct response. -6.21. In the year 1995, what is the difference between the % of GDP of Sub-Saharan Africa (developing only) and % of GDP of Malaysia?
Offer a terse response. -27.08. In the year 1995, what is the difference between the % of GDP in Sub-Saharan Africa (developing only) and % of GDP in Moldova?
Make the answer very short. -8.31. In the year 1995, what is the difference between the % of GDP in Malaysia and % of GDP in Moldova?
Your response must be concise. 18.76. In the year 1996, what is the difference between the % of GDP in Latin America(developing only) and % of GDP in Sub-Saharan Africa (developing only)?
Keep it short and to the point. 2.16. In the year 1996, what is the difference between the % of GDP of Latin America(developing only) and % of GDP of Malaysia?
Your answer should be compact. -22.79. In the year 1996, what is the difference between the % of GDP of Latin America(developing only) and % of GDP of Moldova?
Ensure brevity in your answer.  -5.56. In the year 1996, what is the difference between the % of GDP in Sub-Saharan Africa (developing only) and % of GDP in Malaysia?
Ensure brevity in your answer.  -24.95. In the year 1996, what is the difference between the % of GDP in Sub-Saharan Africa (developing only) and % of GDP in Moldova?
Give a very brief answer. -7.72. In the year 1996, what is the difference between the % of GDP of Malaysia and % of GDP of Moldova?
Provide a short and direct response. 17.23. In the year 1997, what is the difference between the % of GDP in Latin America(developing only) and % of GDP in Sub-Saharan Africa (developing only)?
Provide a short and direct response. 3. In the year 1997, what is the difference between the % of GDP in Latin America(developing only) and % of GDP in Malaysia?
Provide a short and direct response. -23.8. In the year 1997, what is the difference between the % of GDP in Latin America(developing only) and % of GDP in Moldova?
Your answer should be very brief. -4.65. In the year 1997, what is the difference between the % of GDP of Sub-Saharan Africa (developing only) and % of GDP of Malaysia?
Provide a short and direct response. -26.8. In the year 1997, what is the difference between the % of GDP in Sub-Saharan Africa (developing only) and % of GDP in Moldova?
Your response must be concise. -7.64. In the year 1997, what is the difference between the % of GDP in Malaysia and % of GDP in Moldova?
Your answer should be very brief. 19.15. In the year 1998, what is the difference between the % of GDP of Latin America(developing only) and % of GDP of Sub-Saharan Africa (developing only)?
Provide a short and direct response. 2.98. In the year 1998, what is the difference between the % of GDP in Latin America(developing only) and % of GDP in Malaysia?
Keep it short and to the point. -6.42. In the year 1998, what is the difference between the % of GDP of Latin America(developing only) and % of GDP of Moldova?
Make the answer very short. -6.54. In the year 1998, what is the difference between the % of GDP of Sub-Saharan Africa (developing only) and % of GDP of Malaysia?
Your answer should be compact. -9.4. In the year 1998, what is the difference between the % of GDP of Sub-Saharan Africa (developing only) and % of GDP of Moldova?
Make the answer very short. -9.53. In the year 1998, what is the difference between the % of GDP in Malaysia and % of GDP in Moldova?
Your answer should be compact. -0.13. What is the ratio of the % of GDP in Latin America(developing only) in 1991 to that in 1992?
Your answer should be compact. 1.01. What is the ratio of the % of GDP of Sub-Saharan Africa (developing only) in 1991 to that in 1992?
Your response must be concise. 1.1. What is the ratio of the % of GDP in Malaysia in 1991 to that in 1992?
Your response must be concise. 1.07. What is the ratio of the % of GDP of Moldova in 1991 to that in 1992?
Keep it short and to the point. 0.48. What is the ratio of the % of GDP in Latin America(developing only) in 1991 to that in 1993?
Your answer should be very brief. 1.05. What is the ratio of the % of GDP of Sub-Saharan Africa (developing only) in 1991 to that in 1993?
Offer a very short reply. 1.05. What is the ratio of the % of GDP of Malaysia in 1991 to that in 1993?
Your response must be concise. 0.96. What is the ratio of the % of GDP in Moldova in 1991 to that in 1993?
Offer a very short reply. 0.52. What is the ratio of the % of GDP in Latin America(developing only) in 1991 to that in 1994?
Your answer should be very brief. 0.98. What is the ratio of the % of GDP of Sub-Saharan Africa (developing only) in 1991 to that in 1994?
Your answer should be very brief. 0.96. What is the ratio of the % of GDP in Malaysia in 1991 to that in 1994?
Provide a short and direct response. 0.92. What is the ratio of the % of GDP in Moldova in 1991 to that in 1994?
Offer a very short reply. 1. What is the ratio of the % of GDP in Latin America(developing only) in 1991 to that in 1995?
Give a very brief answer. 1.11. What is the ratio of the % of GDP in Malaysia in 1991 to that in 1995?
Provide a succinct answer. 0.87. What is the ratio of the % of GDP of Moldova in 1991 to that in 1995?
Offer a very short reply. 1.16. What is the ratio of the % of GDP in Latin America(developing only) in 1991 to that in 1996?
Your response must be concise. 1.11. What is the ratio of the % of GDP in Malaysia in 1991 to that in 1996?
Offer a terse response. 0.91. What is the ratio of the % of GDP in Moldova in 1991 to that in 1996?
Your answer should be very brief. 1.19. What is the ratio of the % of GDP in Latin America(developing only) in 1991 to that in 1997?
Provide a succinct answer. 1.08. What is the ratio of the % of GDP of Sub-Saharan Africa (developing only) in 1991 to that in 1997?
Offer a terse response. 1.01. What is the ratio of the % of GDP in Malaysia in 1991 to that in 1997?
Make the answer very short. 0.88. What is the ratio of the % of GDP of Moldova in 1991 to that in 1997?
Ensure brevity in your answer.  1.22. What is the ratio of the % of GDP in Latin America(developing only) in 1991 to that in 1998?
Make the answer very short. 1.02. What is the ratio of the % of GDP of Sub-Saharan Africa (developing only) in 1991 to that in 1998?
Keep it short and to the point. 0.95. What is the ratio of the % of GDP in Malaysia in 1991 to that in 1998?
Ensure brevity in your answer.  1.42. What is the ratio of the % of GDP in Moldova in 1991 to that in 1998?
Offer a terse response. 1.08. What is the ratio of the % of GDP in Latin America(developing only) in 1992 to that in 1993?
Offer a very short reply. 1.04. What is the ratio of the % of GDP of Sub-Saharan Africa (developing only) in 1992 to that in 1993?
Give a very brief answer. 0.96. What is the ratio of the % of GDP of Malaysia in 1992 to that in 1993?
Offer a very short reply. 0.9. What is the ratio of the % of GDP of Moldova in 1992 to that in 1993?
Provide a succinct answer. 1.07. What is the ratio of the % of GDP of Latin America(developing only) in 1992 to that in 1994?
Ensure brevity in your answer.  0.97. What is the ratio of the % of GDP in Sub-Saharan Africa (developing only) in 1992 to that in 1994?
Your answer should be compact. 0.87. What is the ratio of the % of GDP in Malaysia in 1992 to that in 1994?
Your answer should be very brief. 0.86. What is the ratio of the % of GDP in Moldova in 1992 to that in 1994?
Provide a succinct answer. 2.07. What is the ratio of the % of GDP of Latin America(developing only) in 1992 to that in 1995?
Provide a succinct answer. 1.09. What is the ratio of the % of GDP of Sub-Saharan Africa (developing only) in 1992 to that in 1995?
Your answer should be very brief. 0.9. What is the ratio of the % of GDP in Malaysia in 1992 to that in 1995?
Your answer should be compact. 0.81. What is the ratio of the % of GDP in Moldova in 1992 to that in 1995?
Give a very brief answer. 2.4. What is the ratio of the % of GDP of Latin America(developing only) in 1992 to that in 1996?
Provide a succinct answer. 1.09. What is the ratio of the % of GDP in Sub-Saharan Africa (developing only) in 1992 to that in 1996?
Provide a succinct answer. 0.9. What is the ratio of the % of GDP of Malaysia in 1992 to that in 1996?
Offer a very short reply. 0.85. What is the ratio of the % of GDP in Moldova in 1992 to that in 1996?
Provide a short and direct response. 2.47. What is the ratio of the % of GDP of Latin America(developing only) in 1992 to that in 1997?
Give a very brief answer. 1.06. What is the ratio of the % of GDP in Sub-Saharan Africa (developing only) in 1992 to that in 1997?
Provide a short and direct response. 0.92. What is the ratio of the % of GDP in Malaysia in 1992 to that in 1997?
Your response must be concise. 0.82. What is the ratio of the % of GDP in Moldova in 1992 to that in 1997?
Your answer should be compact. 2.51. What is the ratio of the % of GDP of Latin America(developing only) in 1992 to that in 1998?
Offer a very short reply. 1.01. What is the ratio of the % of GDP in Sub-Saharan Africa (developing only) in 1992 to that in 1998?
Your answer should be compact. 0.86. What is the ratio of the % of GDP in Malaysia in 1992 to that in 1998?
Your response must be concise. 1.33. What is the ratio of the % of GDP in Moldova in 1992 to that in 1998?
Offer a terse response. 2.23. What is the ratio of the % of GDP of Latin America(developing only) in 1993 to that in 1994?
Offer a terse response. 0.93. What is the ratio of the % of GDP of Sub-Saharan Africa (developing only) in 1993 to that in 1994?
Your answer should be very brief. 0.92. What is the ratio of the % of GDP of Malaysia in 1993 to that in 1994?
Your response must be concise. 0.95. What is the ratio of the % of GDP of Moldova in 1993 to that in 1994?
Ensure brevity in your answer.  1.94. What is the ratio of the % of GDP in Latin America(developing only) in 1993 to that in 1995?
Your answer should be very brief. 1.05. What is the ratio of the % of GDP of Sub-Saharan Africa (developing only) in 1993 to that in 1995?
Provide a succinct answer. 0.94. What is the ratio of the % of GDP in Malaysia in 1993 to that in 1995?
Provide a short and direct response. 0.9. What is the ratio of the % of GDP in Moldova in 1993 to that in 1995?
Provide a succinct answer. 2.24. What is the ratio of the % of GDP of Latin America(developing only) in 1993 to that in 1996?
Ensure brevity in your answer.  1.05. What is the ratio of the % of GDP of Sub-Saharan Africa (developing only) in 1993 to that in 1996?
Your response must be concise. 0.94. What is the ratio of the % of GDP in Malaysia in 1993 to that in 1996?
Keep it short and to the point. 0.94. What is the ratio of the % of GDP of Moldova in 1993 to that in 1996?
Your answer should be very brief. 2.3. What is the ratio of the % of GDP of Latin America(developing only) in 1993 to that in 1997?
Offer a terse response. 1.02. What is the ratio of the % of GDP of Sub-Saharan Africa (developing only) in 1993 to that in 1997?
Provide a succinct answer. 0.96. What is the ratio of the % of GDP in Malaysia in 1993 to that in 1997?
Make the answer very short. 0.91. What is the ratio of the % of GDP in Moldova in 1993 to that in 1997?
Offer a very short reply. 2.34. What is the ratio of the % of GDP of Latin America(developing only) in 1993 to that in 1998?
Your response must be concise. 0.97. What is the ratio of the % of GDP of Sub-Saharan Africa (developing only) in 1993 to that in 1998?
Provide a succinct answer. 0.9. What is the ratio of the % of GDP in Malaysia in 1993 to that in 1998?
Ensure brevity in your answer.  1.47. What is the ratio of the % of GDP of Moldova in 1993 to that in 1998?
Give a very brief answer. 2.08. What is the ratio of the % of GDP in Latin America(developing only) in 1994 to that in 1995?
Your response must be concise. 1.13. What is the ratio of the % of GDP of Sub-Saharan Africa (developing only) in 1994 to that in 1995?
Keep it short and to the point. 1.03. What is the ratio of the % of GDP in Malaysia in 1994 to that in 1995?
Your response must be concise. 0.94. What is the ratio of the % of GDP of Moldova in 1994 to that in 1995?
Your response must be concise. 1.16. What is the ratio of the % of GDP of Latin America(developing only) in 1994 to that in 1996?
Provide a short and direct response. 1.13. What is the ratio of the % of GDP in Sub-Saharan Africa (developing only) in 1994 to that in 1996?
Keep it short and to the point. 1.03. What is the ratio of the % of GDP in Malaysia in 1994 to that in 1996?
Offer a terse response. 0.99. What is the ratio of the % of GDP in Moldova in 1994 to that in 1996?
Your answer should be compact. 1.19. What is the ratio of the % of GDP in Latin America(developing only) in 1994 to that in 1997?
Your answer should be compact. 1.1. What is the ratio of the % of GDP in Sub-Saharan Africa (developing only) in 1994 to that in 1997?
Offer a terse response. 1.05. What is the ratio of the % of GDP in Malaysia in 1994 to that in 1997?
Your answer should be compact. 0.96. What is the ratio of the % of GDP of Moldova in 1994 to that in 1997?
Provide a succinct answer. 1.21. What is the ratio of the % of GDP of Latin America(developing only) in 1994 to that in 1998?
Your response must be concise. 1.04. What is the ratio of the % of GDP of Sub-Saharan Africa (developing only) in 1994 to that in 1998?
Offer a terse response. 0.99. What is the ratio of the % of GDP in Malaysia in 1994 to that in 1998?
Keep it short and to the point. 1.54. What is the ratio of the % of GDP of Moldova in 1994 to that in 1998?
Your answer should be compact. 1.08. What is the ratio of the % of GDP of Sub-Saharan Africa (developing only) in 1995 to that in 1996?
Your response must be concise. 1. What is the ratio of the % of GDP in Malaysia in 1995 to that in 1996?
Make the answer very short. 1.05. What is the ratio of the % of GDP of Moldova in 1995 to that in 1996?
Give a very brief answer. 1.03. What is the ratio of the % of GDP in Latin America(developing only) in 1995 to that in 1997?
Your answer should be very brief. 0.97. What is the ratio of the % of GDP of Sub-Saharan Africa (developing only) in 1995 to that in 1997?
Provide a short and direct response. 1.02. What is the ratio of the % of GDP in Malaysia in 1995 to that in 1997?
Offer a very short reply. 1.02. What is the ratio of the % of GDP of Moldova in 1995 to that in 1997?
Provide a succinct answer. 1.04. What is the ratio of the % of GDP in Latin America(developing only) in 1995 to that in 1998?
Your answer should be very brief. 0.92. What is the ratio of the % of GDP of Sub-Saharan Africa (developing only) in 1995 to that in 1998?
Provide a short and direct response. 0.96. What is the ratio of the % of GDP in Malaysia in 1995 to that in 1998?
Provide a succinct answer. 1.64. What is the ratio of the % of GDP of Moldova in 1995 to that in 1998?
Make the answer very short. 0.93. What is the ratio of the % of GDP of Latin America(developing only) in 1996 to that in 1997?
Keep it short and to the point. 0.97. What is the ratio of the % of GDP of Sub-Saharan Africa (developing only) in 1996 to that in 1997?
Give a very brief answer. 1.02. What is the ratio of the % of GDP of Malaysia in 1996 to that in 1997?
Provide a succinct answer. 0.97. What is the ratio of the % of GDP of Moldova in 1996 to that in 1997?
Your answer should be compact. 1.02. What is the ratio of the % of GDP in Latin America(developing only) in 1996 to that in 1998?
Offer a terse response. 0.92. What is the ratio of the % of GDP in Sub-Saharan Africa (developing only) in 1996 to that in 1998?
Give a very brief answer. 0.96. What is the ratio of the % of GDP in Malaysia in 1996 to that in 1998?
Provide a short and direct response. 1.55. What is the ratio of the % of GDP in Moldova in 1996 to that in 1998?
Provide a succinct answer. 0.9. What is the ratio of the % of GDP in Latin America(developing only) in 1997 to that in 1998?
Your answer should be compact. 0.95. What is the ratio of the % of GDP of Sub-Saharan Africa (developing only) in 1997 to that in 1998?
Your answer should be compact. 0.94. What is the ratio of the % of GDP in Malaysia in 1997 to that in 1998?
Make the answer very short. 1.61. What is the ratio of the % of GDP in Moldova in 1997 to that in 1998?
Ensure brevity in your answer.  0.89. What is the difference between the highest and the second highest % of GDP in Latin America(developing only)?
Ensure brevity in your answer.  0.39. What is the difference between the highest and the second highest % of GDP in Sub-Saharan Africa (developing only)?
Offer a terse response. 0.25. What is the difference between the highest and the second highest % of GDP in Malaysia?
Your answer should be very brief. 0.67. What is the difference between the highest and the second highest % of GDP of Moldova?
Your answer should be compact. 3.97. What is the difference between the highest and the lowest % of GDP of Latin America(developing only)?
Provide a short and direct response. 2.37. What is the difference between the highest and the lowest % of GDP in Sub-Saharan Africa (developing only)?
Offer a terse response. 2.39. What is the difference between the highest and the lowest % of GDP in Malaysia?
Your answer should be compact. 16.97. What is the difference between the highest and the lowest % of GDP in Moldova?
Provide a short and direct response. 35.95. 